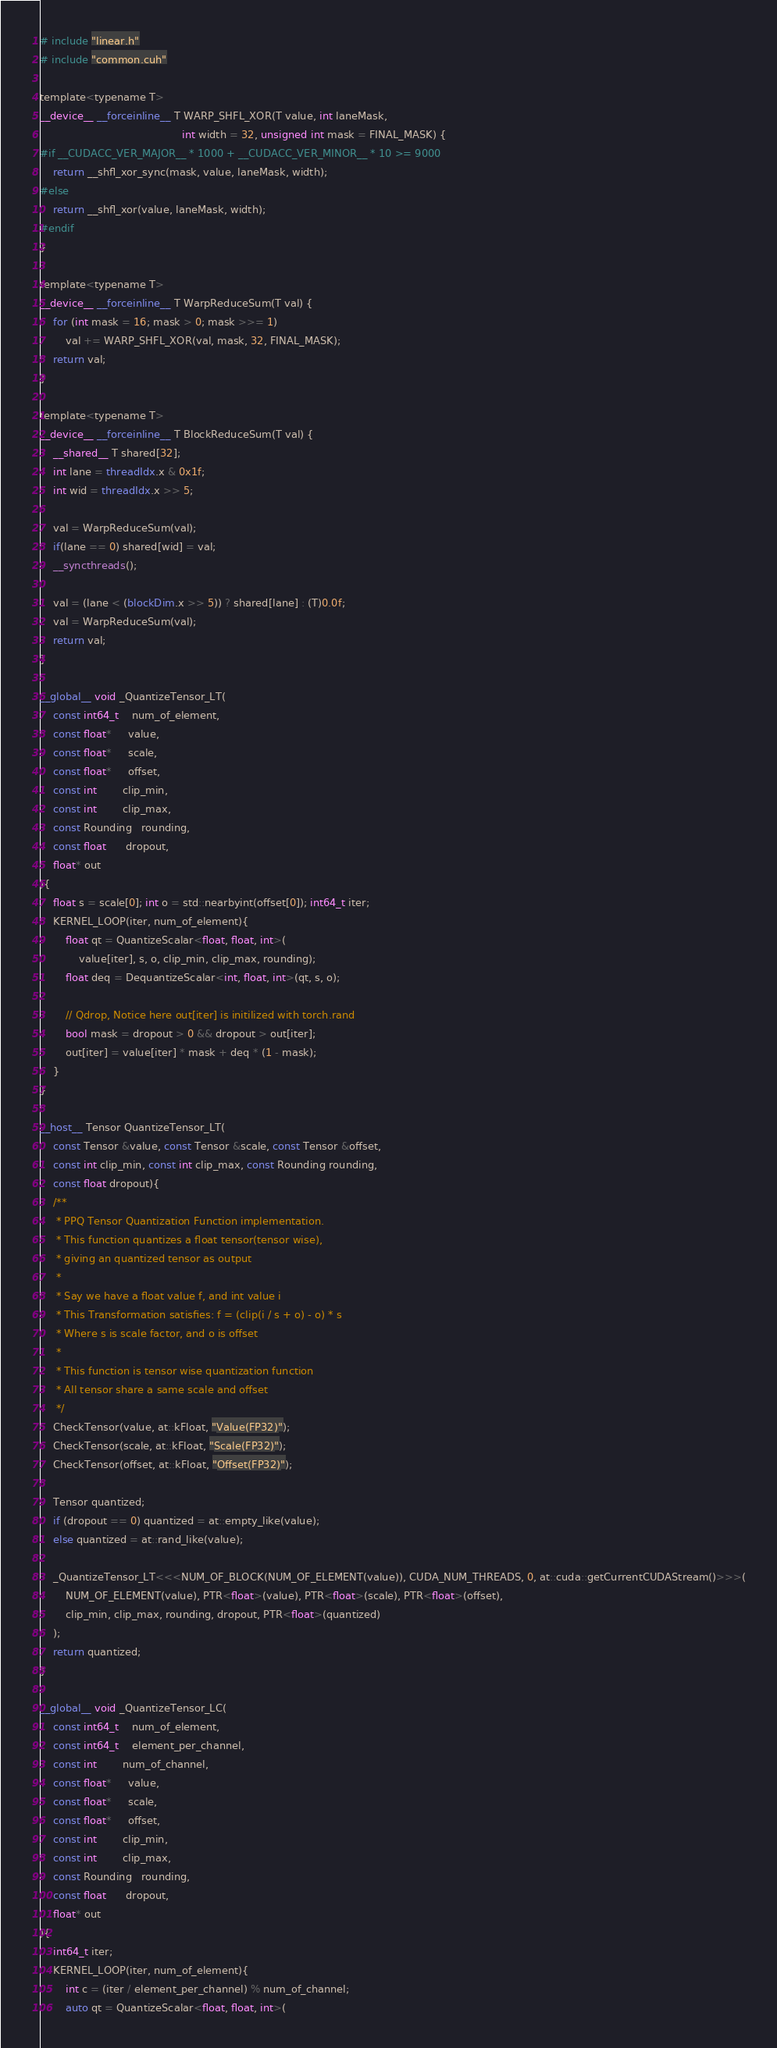Convert code to text. <code><loc_0><loc_0><loc_500><loc_500><_Cuda_># include "linear.h"
# include "common.cuh"

template<typename T>
__device__ __forceinline__ T WARP_SHFL_XOR(T value, int laneMask,
                                            int width = 32, unsigned int mask = FINAL_MASK) {
#if __CUDACC_VER_MAJOR__ * 1000 + __CUDACC_VER_MINOR__ * 10 >= 9000
    return __shfl_xor_sync(mask, value, laneMask, width);
#else
    return __shfl_xor(value, laneMask, width);
#endif
}

template<typename T>
__device__ __forceinline__ T WarpReduceSum(T val) {
    for (int mask = 16; mask > 0; mask >>= 1)
        val += WARP_SHFL_XOR(val, mask, 32, FINAL_MASK);
    return val;
}

template<typename T>
__device__ __forceinline__ T BlockReduceSum(T val) {
    __shared__ T shared[32];
    int lane = threadIdx.x & 0x1f;
    int wid = threadIdx.x >> 5;

    val = WarpReduceSum(val);
    if(lane == 0) shared[wid] = val;
    __syncthreads();

    val = (lane < (blockDim.x >> 5)) ? shared[lane] : (T)0.0f;
    val = WarpReduceSum(val);
    return val;
}

__global__ void _QuantizeTensor_LT(
    const int64_t    num_of_element,
    const float*     value,
    const float*     scale,
    const float*     offset,
    const int        clip_min,
    const int        clip_max,
    const Rounding   rounding,
    const float      dropout,
    float* out
){
    float s = scale[0]; int o = std::nearbyint(offset[0]); int64_t iter;
    KERNEL_LOOP(iter, num_of_element){
        float qt = QuantizeScalar<float, float, int>(
            value[iter], s, o, clip_min, clip_max, rounding);
        float deq = DequantizeScalar<int, float, int>(qt, s, o);

        // Qdrop, Notice here out[iter] is initilized with torch.rand
        bool mask = dropout > 0 && dropout > out[iter];
        out[iter] = value[iter] * mask + deq * (1 - mask);
    }
}

__host__ Tensor QuantizeTensor_LT(
    const Tensor &value, const Tensor &scale, const Tensor &offset, 
    const int clip_min, const int clip_max, const Rounding rounding,  
    const float dropout){
    /** 
     * PPQ Tensor Quantization Function implementation.
     * This function quantizes a float tensor(tensor wise), 
     * giving an quantized tensor as output 
     * 
     * Say we have a float value f, and int value i
     * This Transformation satisfies: f = (clip(i / s + o) - o) * s
     * Where s is scale factor, and o is offset
     * 
     * This function is tensor wise quantization function
     * All tensor share a same scale and offset
     */
    CheckTensor(value, at::kFloat, "Value(FP32)");
    CheckTensor(scale, at::kFloat, "Scale(FP32)");
    CheckTensor(offset, at::kFloat, "Offset(FP32)");

    Tensor quantized;
    if (dropout == 0) quantized = at::empty_like(value);
    else quantized = at::rand_like(value);

    _QuantizeTensor_LT<<<NUM_OF_BLOCK(NUM_OF_ELEMENT(value)), CUDA_NUM_THREADS, 0, at::cuda::getCurrentCUDAStream()>>>(
        NUM_OF_ELEMENT(value), PTR<float>(value), PTR<float>(scale), PTR<float>(offset),
        clip_min, clip_max, rounding, dropout, PTR<float>(quantized)
    );
    return quantized;
}

__global__ void _QuantizeTensor_LC(
    const int64_t    num_of_element,
    const int64_t    element_per_channel,
    const int        num_of_channel,
    const float*     value,
    const float*     scale,
    const float*     offset,
    const int        clip_min,
    const int        clip_max,
    const Rounding   rounding,
    const float      dropout,
    float* out
){
    int64_t iter;
    KERNEL_LOOP(iter, num_of_element){
        int c = (iter / element_per_channel) % num_of_channel;
        auto qt = QuantizeScalar<float, float, int>(</code> 